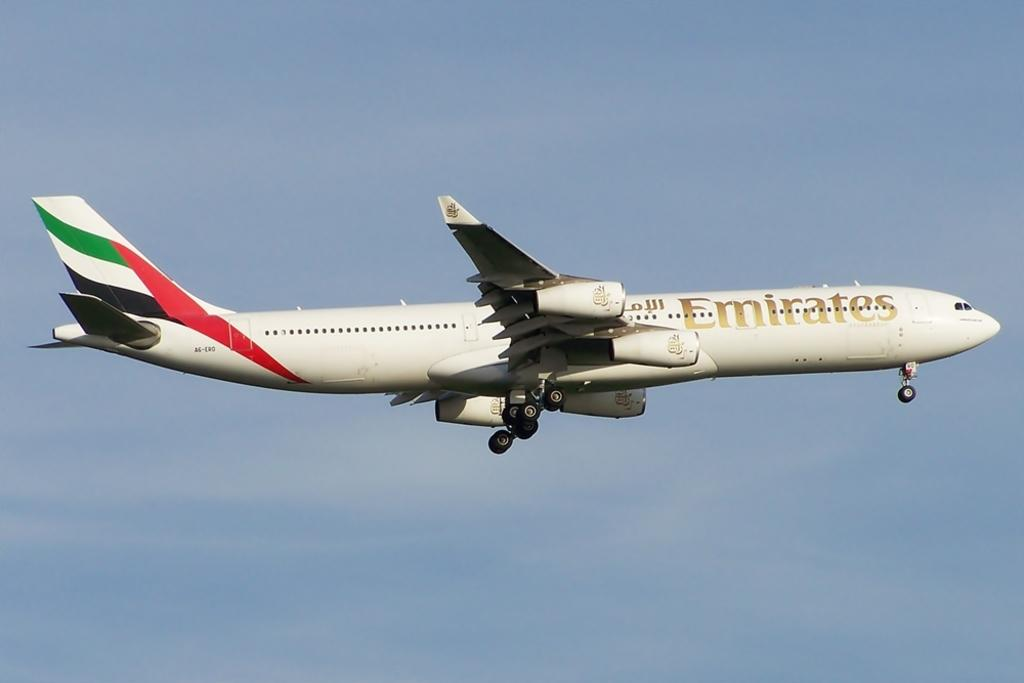<image>
Render a clear and concise summary of the photo. emirates airplane flying in the sky a clear day 